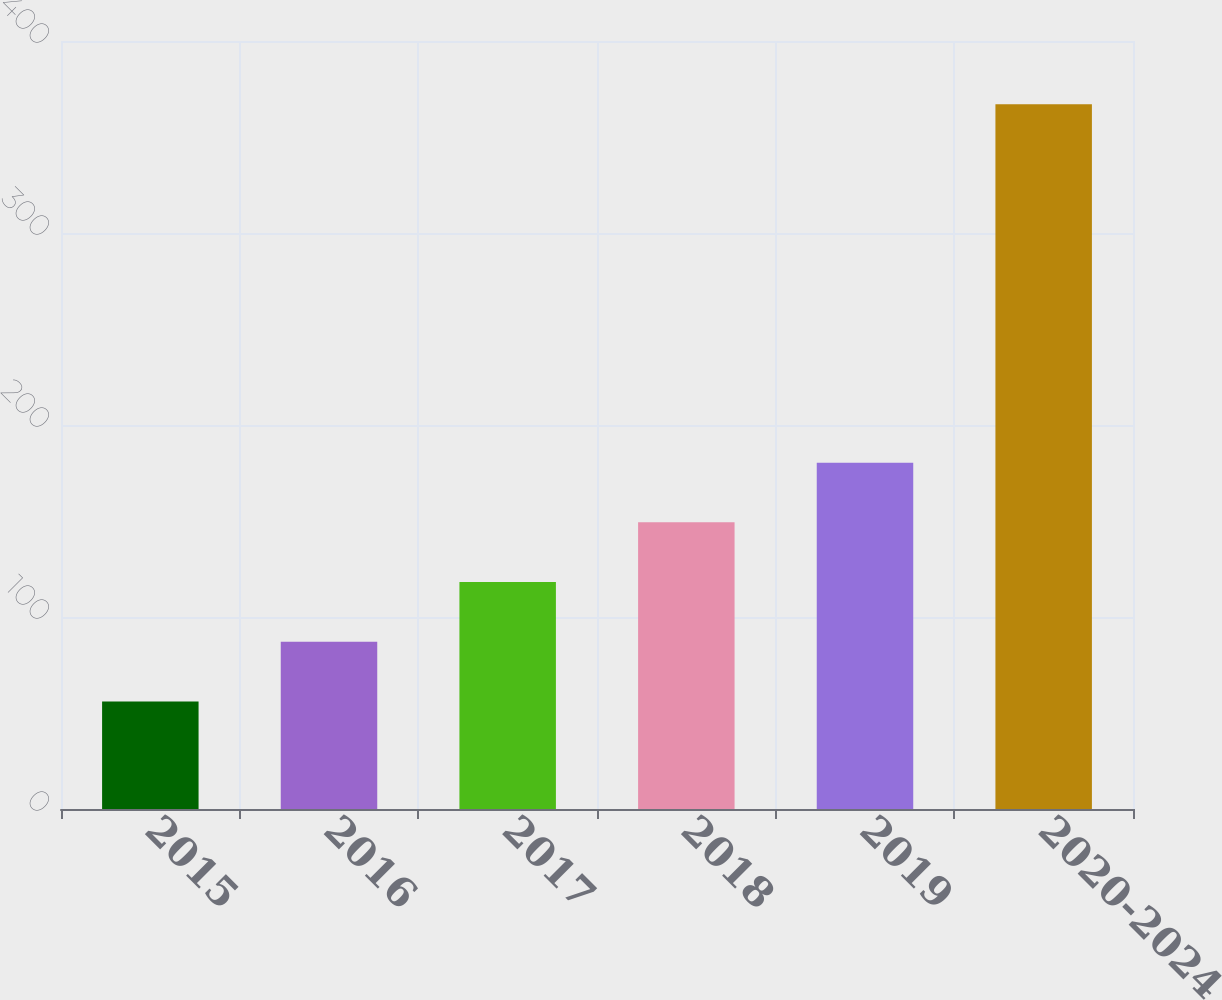<chart> <loc_0><loc_0><loc_500><loc_500><bar_chart><fcel>2015<fcel>2016<fcel>2017<fcel>2018<fcel>2019<fcel>2020-2024<nl><fcel>56<fcel>87.1<fcel>118.2<fcel>149.3<fcel>180.4<fcel>367<nl></chart> 